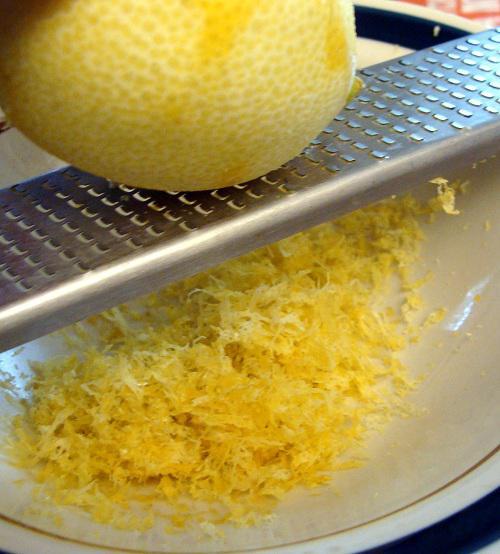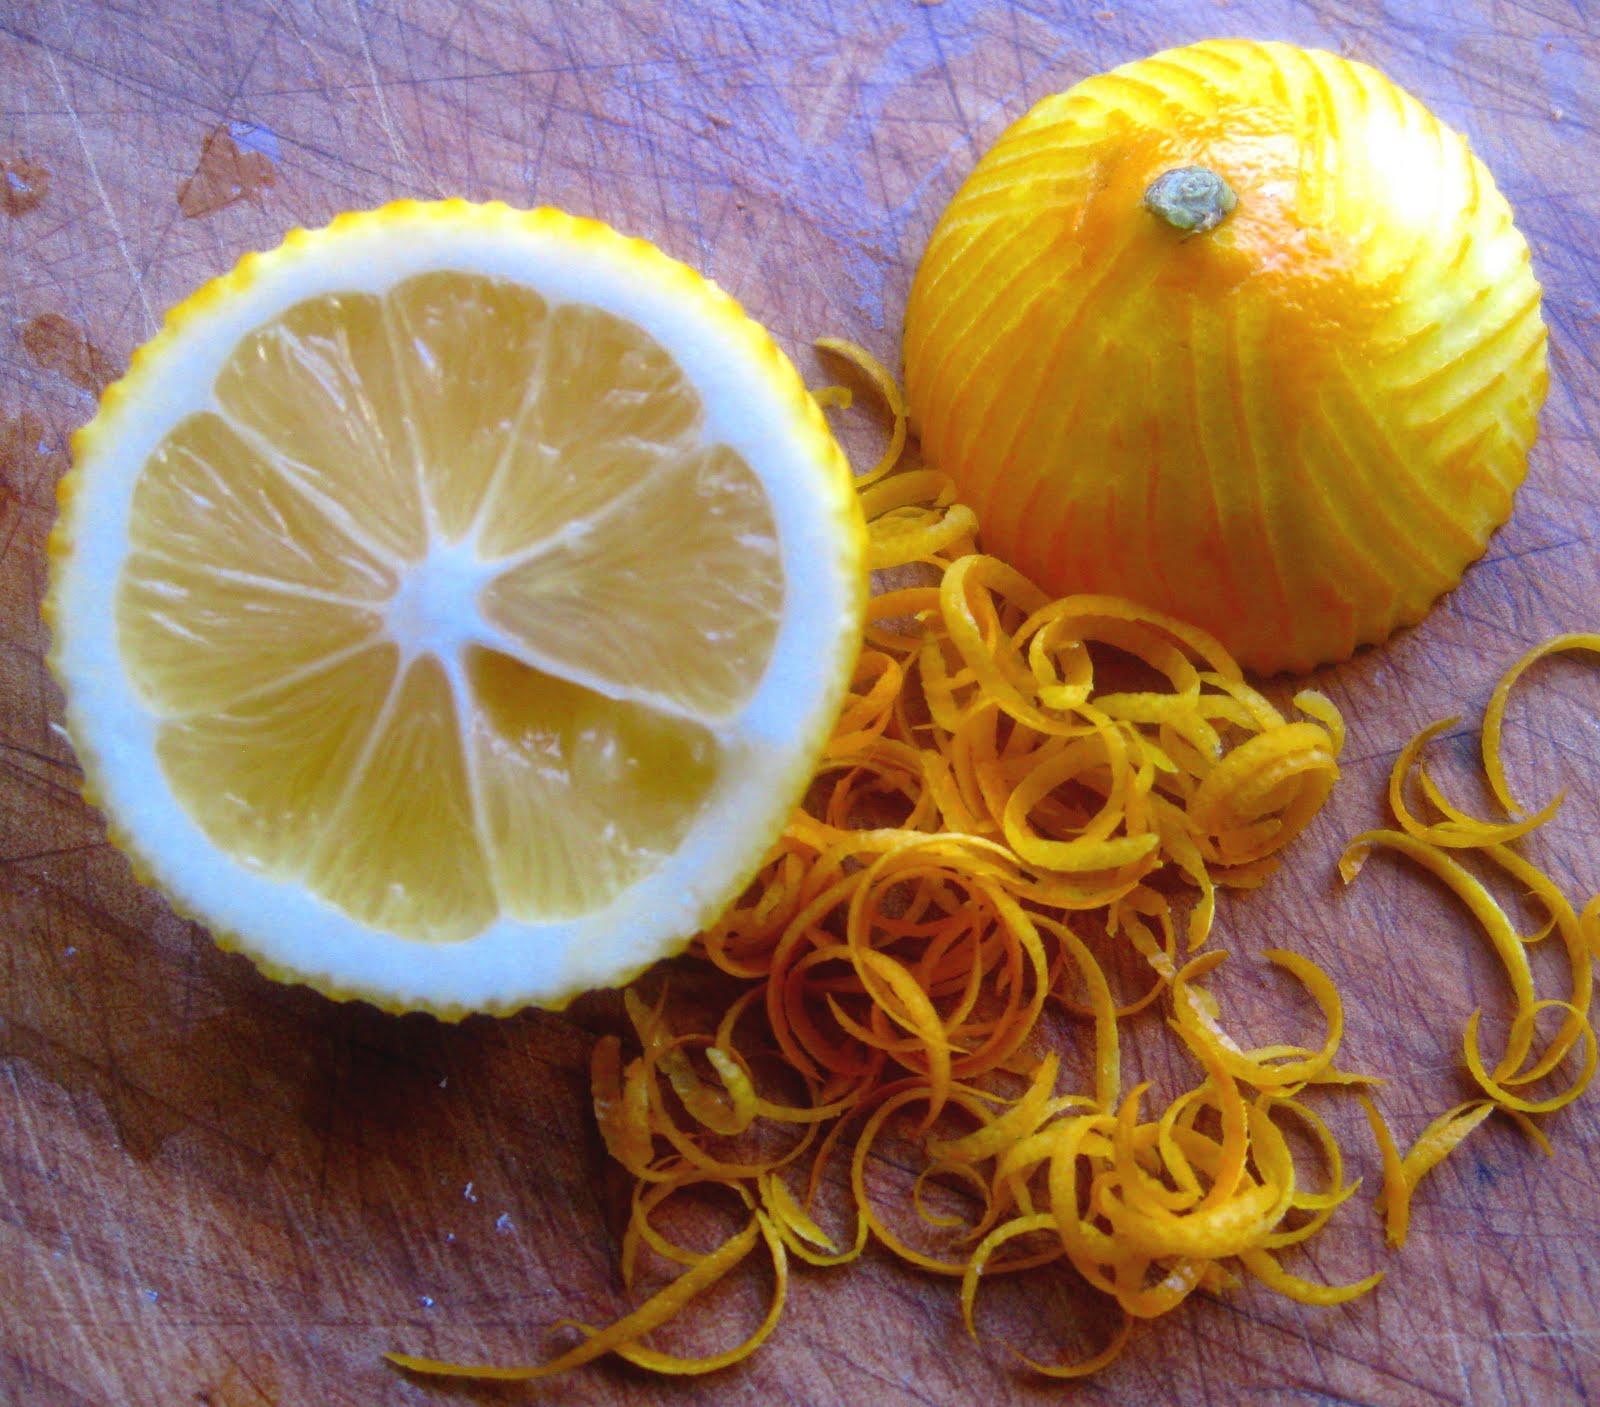The first image is the image on the left, the second image is the image on the right. Evaluate the accuracy of this statement regarding the images: "A lemon is on a microplane zester and there is a pile of finely shaved lemon zest.". Is it true? Answer yes or no. Yes. The first image is the image on the left, the second image is the image on the right. For the images shown, is this caption "One lemon is cut in half." true? Answer yes or no. Yes. 